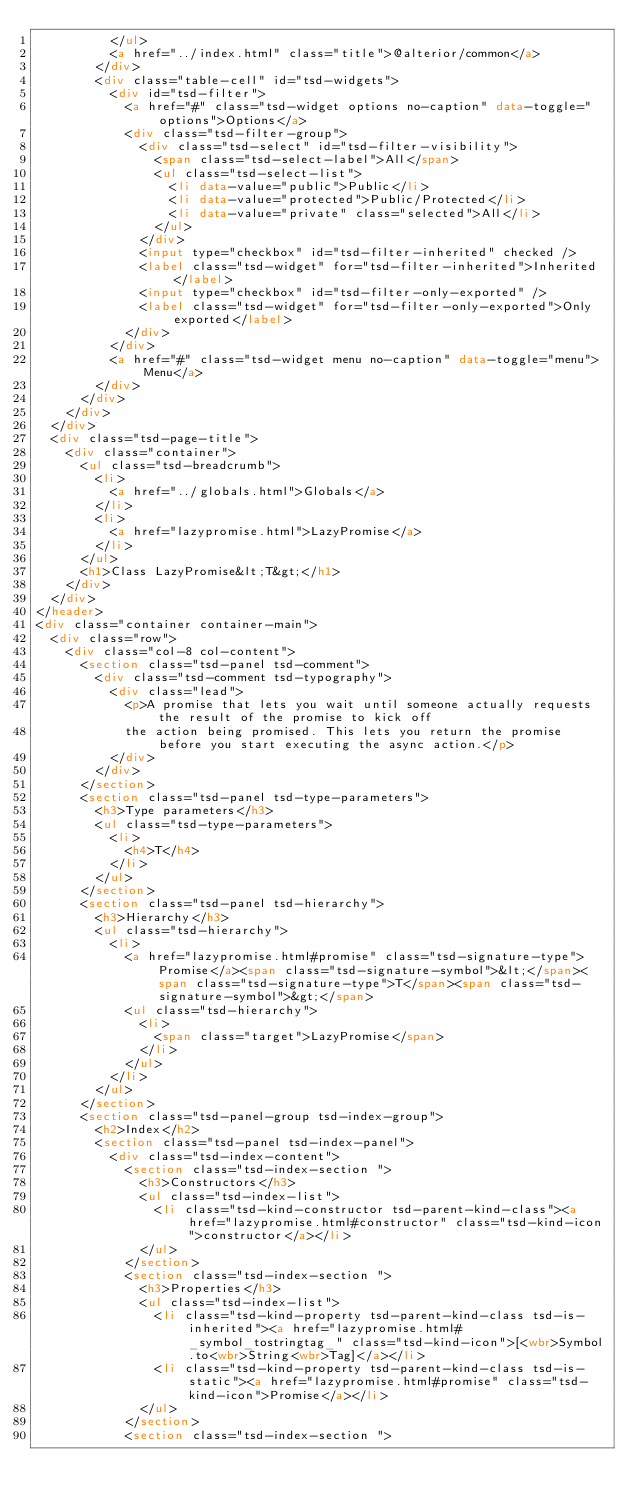Convert code to text. <code><loc_0><loc_0><loc_500><loc_500><_HTML_>					</ul>
					<a href="../index.html" class="title">@alterior/common</a>
				</div>
				<div class="table-cell" id="tsd-widgets">
					<div id="tsd-filter">
						<a href="#" class="tsd-widget options no-caption" data-toggle="options">Options</a>
						<div class="tsd-filter-group">
							<div class="tsd-select" id="tsd-filter-visibility">
								<span class="tsd-select-label">All</span>
								<ul class="tsd-select-list">
									<li data-value="public">Public</li>
									<li data-value="protected">Public/Protected</li>
									<li data-value="private" class="selected">All</li>
								</ul>
							</div>
							<input type="checkbox" id="tsd-filter-inherited" checked />
							<label class="tsd-widget" for="tsd-filter-inherited">Inherited</label>
							<input type="checkbox" id="tsd-filter-only-exported" />
							<label class="tsd-widget" for="tsd-filter-only-exported">Only exported</label>
						</div>
					</div>
					<a href="#" class="tsd-widget menu no-caption" data-toggle="menu">Menu</a>
				</div>
			</div>
		</div>
	</div>
	<div class="tsd-page-title">
		<div class="container">
			<ul class="tsd-breadcrumb">
				<li>
					<a href="../globals.html">Globals</a>
				</li>
				<li>
					<a href="lazypromise.html">LazyPromise</a>
				</li>
			</ul>
			<h1>Class LazyPromise&lt;T&gt;</h1>
		</div>
	</div>
</header>
<div class="container container-main">
	<div class="row">
		<div class="col-8 col-content">
			<section class="tsd-panel tsd-comment">
				<div class="tsd-comment tsd-typography">
					<div class="lead">
						<p>A promise that lets you wait until someone actually requests the result of the promise to kick off
						the action being promised. This lets you return the promise before you start executing the async action.</p>
					</div>
				</div>
			</section>
			<section class="tsd-panel tsd-type-parameters">
				<h3>Type parameters</h3>
				<ul class="tsd-type-parameters">
					<li>
						<h4>T</h4>
					</li>
				</ul>
			</section>
			<section class="tsd-panel tsd-hierarchy">
				<h3>Hierarchy</h3>
				<ul class="tsd-hierarchy">
					<li>
						<a href="lazypromise.html#promise" class="tsd-signature-type">Promise</a><span class="tsd-signature-symbol">&lt;</span><span class="tsd-signature-type">T</span><span class="tsd-signature-symbol">&gt;</span>
						<ul class="tsd-hierarchy">
							<li>
								<span class="target">LazyPromise</span>
							</li>
						</ul>
					</li>
				</ul>
			</section>
			<section class="tsd-panel-group tsd-index-group">
				<h2>Index</h2>
				<section class="tsd-panel tsd-index-panel">
					<div class="tsd-index-content">
						<section class="tsd-index-section ">
							<h3>Constructors</h3>
							<ul class="tsd-index-list">
								<li class="tsd-kind-constructor tsd-parent-kind-class"><a href="lazypromise.html#constructor" class="tsd-kind-icon">constructor</a></li>
							</ul>
						</section>
						<section class="tsd-index-section ">
							<h3>Properties</h3>
							<ul class="tsd-index-list">
								<li class="tsd-kind-property tsd-parent-kind-class tsd-is-inherited"><a href="lazypromise.html#_symbol_tostringtag_" class="tsd-kind-icon">[<wbr>Symbol.to<wbr>String<wbr>Tag]</a></li>
								<li class="tsd-kind-property tsd-parent-kind-class tsd-is-static"><a href="lazypromise.html#promise" class="tsd-kind-icon">Promise</a></li>
							</ul>
						</section>
						<section class="tsd-index-section "></code> 